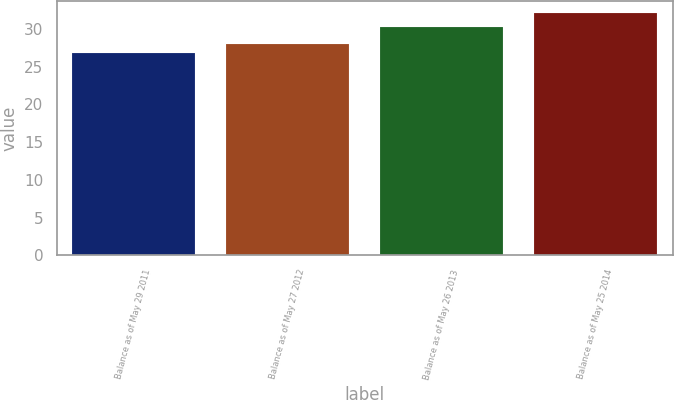<chart> <loc_0><loc_0><loc_500><loc_500><bar_chart><fcel>Balance as of May 29 2011<fcel>Balance as of May 27 2012<fcel>Balance as of May 26 2013<fcel>Balance as of May 25 2014<nl><fcel>26.82<fcel>27.96<fcel>30.22<fcel>32.1<nl></chart> 